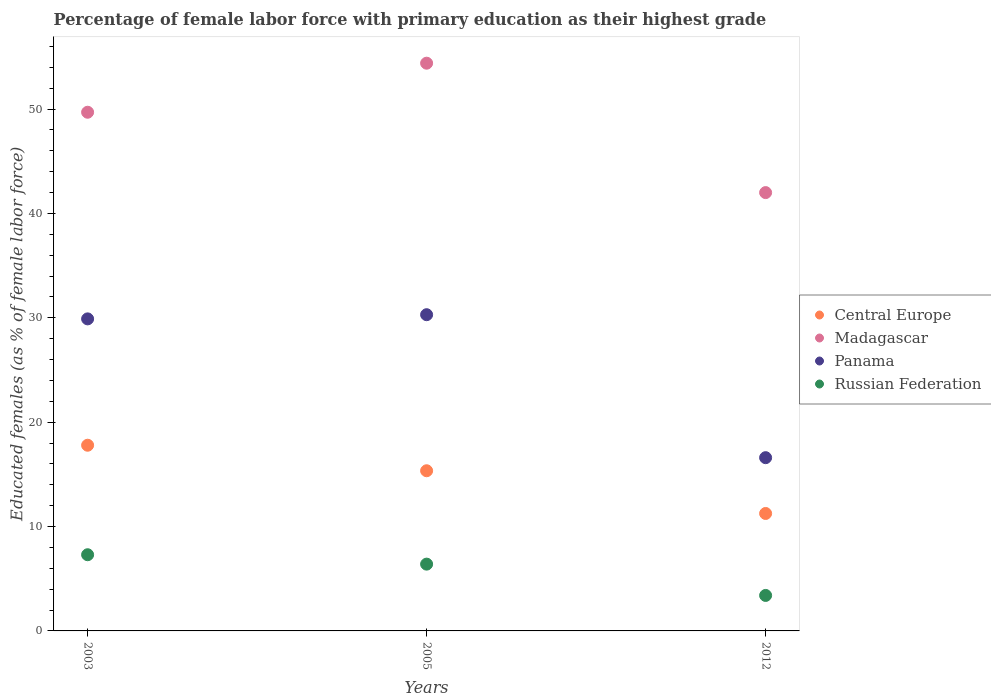What is the percentage of female labor force with primary education in Madagascar in 2003?
Offer a terse response. 49.7. Across all years, what is the maximum percentage of female labor force with primary education in Russian Federation?
Offer a very short reply. 7.3. Across all years, what is the minimum percentage of female labor force with primary education in Central Europe?
Ensure brevity in your answer.  11.25. In which year was the percentage of female labor force with primary education in Panama maximum?
Offer a very short reply. 2005. In which year was the percentage of female labor force with primary education in Panama minimum?
Your answer should be compact. 2012. What is the total percentage of female labor force with primary education in Madagascar in the graph?
Provide a short and direct response. 146.1. What is the difference between the percentage of female labor force with primary education in Russian Federation in 2003 and that in 2005?
Give a very brief answer. 0.9. What is the difference between the percentage of female labor force with primary education in Panama in 2003 and the percentage of female labor force with primary education in Russian Federation in 2012?
Make the answer very short. 26.5. What is the average percentage of female labor force with primary education in Panama per year?
Offer a very short reply. 25.6. In the year 2005, what is the difference between the percentage of female labor force with primary education in Madagascar and percentage of female labor force with primary education in Russian Federation?
Offer a very short reply. 48. In how many years, is the percentage of female labor force with primary education in Panama greater than 24 %?
Provide a short and direct response. 2. What is the ratio of the percentage of female labor force with primary education in Madagascar in 2005 to that in 2012?
Provide a short and direct response. 1.3. Is the percentage of female labor force with primary education in Russian Federation in 2003 less than that in 2012?
Provide a short and direct response. No. What is the difference between the highest and the second highest percentage of female labor force with primary education in Panama?
Your answer should be compact. 0.4. What is the difference between the highest and the lowest percentage of female labor force with primary education in Russian Federation?
Provide a succinct answer. 3.9. In how many years, is the percentage of female labor force with primary education in Central Europe greater than the average percentage of female labor force with primary education in Central Europe taken over all years?
Give a very brief answer. 2. Is the sum of the percentage of female labor force with primary education in Panama in 2003 and 2012 greater than the maximum percentage of female labor force with primary education in Madagascar across all years?
Make the answer very short. No. Is it the case that in every year, the sum of the percentage of female labor force with primary education in Madagascar and percentage of female labor force with primary education in Central Europe  is greater than the sum of percentage of female labor force with primary education in Panama and percentage of female labor force with primary education in Russian Federation?
Provide a short and direct response. Yes. Is it the case that in every year, the sum of the percentage of female labor force with primary education in Russian Federation and percentage of female labor force with primary education in Panama  is greater than the percentage of female labor force with primary education in Central Europe?
Your answer should be very brief. Yes. Is the percentage of female labor force with primary education in Madagascar strictly less than the percentage of female labor force with primary education in Russian Federation over the years?
Your response must be concise. No. Does the graph contain any zero values?
Make the answer very short. No. What is the title of the graph?
Ensure brevity in your answer.  Percentage of female labor force with primary education as their highest grade. What is the label or title of the X-axis?
Your answer should be compact. Years. What is the label or title of the Y-axis?
Make the answer very short. Educated females (as % of female labor force). What is the Educated females (as % of female labor force) of Central Europe in 2003?
Offer a terse response. 17.79. What is the Educated females (as % of female labor force) in Madagascar in 2003?
Offer a terse response. 49.7. What is the Educated females (as % of female labor force) in Panama in 2003?
Keep it short and to the point. 29.9. What is the Educated females (as % of female labor force) in Russian Federation in 2003?
Provide a short and direct response. 7.3. What is the Educated females (as % of female labor force) in Central Europe in 2005?
Provide a succinct answer. 15.35. What is the Educated females (as % of female labor force) in Madagascar in 2005?
Offer a very short reply. 54.4. What is the Educated females (as % of female labor force) in Panama in 2005?
Your response must be concise. 30.3. What is the Educated females (as % of female labor force) of Russian Federation in 2005?
Your response must be concise. 6.4. What is the Educated females (as % of female labor force) in Central Europe in 2012?
Provide a short and direct response. 11.25. What is the Educated females (as % of female labor force) of Madagascar in 2012?
Your answer should be very brief. 42. What is the Educated females (as % of female labor force) in Panama in 2012?
Your answer should be compact. 16.6. What is the Educated females (as % of female labor force) in Russian Federation in 2012?
Ensure brevity in your answer.  3.4. Across all years, what is the maximum Educated females (as % of female labor force) in Central Europe?
Provide a succinct answer. 17.79. Across all years, what is the maximum Educated females (as % of female labor force) of Madagascar?
Your response must be concise. 54.4. Across all years, what is the maximum Educated females (as % of female labor force) of Panama?
Your response must be concise. 30.3. Across all years, what is the maximum Educated females (as % of female labor force) in Russian Federation?
Provide a short and direct response. 7.3. Across all years, what is the minimum Educated females (as % of female labor force) in Central Europe?
Provide a succinct answer. 11.25. Across all years, what is the minimum Educated females (as % of female labor force) of Panama?
Provide a succinct answer. 16.6. Across all years, what is the minimum Educated females (as % of female labor force) of Russian Federation?
Offer a very short reply. 3.4. What is the total Educated females (as % of female labor force) of Central Europe in the graph?
Your response must be concise. 44.39. What is the total Educated females (as % of female labor force) in Madagascar in the graph?
Provide a succinct answer. 146.1. What is the total Educated females (as % of female labor force) of Panama in the graph?
Your answer should be compact. 76.8. What is the difference between the Educated females (as % of female labor force) of Central Europe in 2003 and that in 2005?
Your answer should be very brief. 2.45. What is the difference between the Educated females (as % of female labor force) of Madagascar in 2003 and that in 2005?
Give a very brief answer. -4.7. What is the difference between the Educated females (as % of female labor force) of Central Europe in 2003 and that in 2012?
Give a very brief answer. 6.54. What is the difference between the Educated females (as % of female labor force) in Madagascar in 2003 and that in 2012?
Keep it short and to the point. 7.7. What is the difference between the Educated females (as % of female labor force) in Central Europe in 2005 and that in 2012?
Your answer should be very brief. 4.09. What is the difference between the Educated females (as % of female labor force) of Madagascar in 2005 and that in 2012?
Your answer should be compact. 12.4. What is the difference between the Educated females (as % of female labor force) of Central Europe in 2003 and the Educated females (as % of female labor force) of Madagascar in 2005?
Provide a short and direct response. -36.61. What is the difference between the Educated females (as % of female labor force) in Central Europe in 2003 and the Educated females (as % of female labor force) in Panama in 2005?
Your answer should be compact. -12.51. What is the difference between the Educated females (as % of female labor force) of Central Europe in 2003 and the Educated females (as % of female labor force) of Russian Federation in 2005?
Provide a short and direct response. 11.39. What is the difference between the Educated females (as % of female labor force) of Madagascar in 2003 and the Educated females (as % of female labor force) of Panama in 2005?
Offer a terse response. 19.4. What is the difference between the Educated females (as % of female labor force) of Madagascar in 2003 and the Educated females (as % of female labor force) of Russian Federation in 2005?
Make the answer very short. 43.3. What is the difference between the Educated females (as % of female labor force) in Central Europe in 2003 and the Educated females (as % of female labor force) in Madagascar in 2012?
Make the answer very short. -24.21. What is the difference between the Educated females (as % of female labor force) in Central Europe in 2003 and the Educated females (as % of female labor force) in Panama in 2012?
Your response must be concise. 1.19. What is the difference between the Educated females (as % of female labor force) of Central Europe in 2003 and the Educated females (as % of female labor force) of Russian Federation in 2012?
Make the answer very short. 14.39. What is the difference between the Educated females (as % of female labor force) in Madagascar in 2003 and the Educated females (as % of female labor force) in Panama in 2012?
Keep it short and to the point. 33.1. What is the difference between the Educated females (as % of female labor force) of Madagascar in 2003 and the Educated females (as % of female labor force) of Russian Federation in 2012?
Keep it short and to the point. 46.3. What is the difference between the Educated females (as % of female labor force) of Central Europe in 2005 and the Educated females (as % of female labor force) of Madagascar in 2012?
Keep it short and to the point. -26.65. What is the difference between the Educated females (as % of female labor force) of Central Europe in 2005 and the Educated females (as % of female labor force) of Panama in 2012?
Keep it short and to the point. -1.25. What is the difference between the Educated females (as % of female labor force) of Central Europe in 2005 and the Educated females (as % of female labor force) of Russian Federation in 2012?
Provide a succinct answer. 11.95. What is the difference between the Educated females (as % of female labor force) in Madagascar in 2005 and the Educated females (as % of female labor force) in Panama in 2012?
Provide a short and direct response. 37.8. What is the difference between the Educated females (as % of female labor force) in Madagascar in 2005 and the Educated females (as % of female labor force) in Russian Federation in 2012?
Offer a very short reply. 51. What is the difference between the Educated females (as % of female labor force) in Panama in 2005 and the Educated females (as % of female labor force) in Russian Federation in 2012?
Offer a very short reply. 26.9. What is the average Educated females (as % of female labor force) of Central Europe per year?
Provide a short and direct response. 14.8. What is the average Educated females (as % of female labor force) in Madagascar per year?
Offer a very short reply. 48.7. What is the average Educated females (as % of female labor force) in Panama per year?
Keep it short and to the point. 25.6. In the year 2003, what is the difference between the Educated females (as % of female labor force) in Central Europe and Educated females (as % of female labor force) in Madagascar?
Provide a succinct answer. -31.91. In the year 2003, what is the difference between the Educated females (as % of female labor force) of Central Europe and Educated females (as % of female labor force) of Panama?
Offer a very short reply. -12.11. In the year 2003, what is the difference between the Educated females (as % of female labor force) of Central Europe and Educated females (as % of female labor force) of Russian Federation?
Provide a succinct answer. 10.49. In the year 2003, what is the difference between the Educated females (as % of female labor force) in Madagascar and Educated females (as % of female labor force) in Panama?
Keep it short and to the point. 19.8. In the year 2003, what is the difference between the Educated females (as % of female labor force) in Madagascar and Educated females (as % of female labor force) in Russian Federation?
Your response must be concise. 42.4. In the year 2003, what is the difference between the Educated females (as % of female labor force) of Panama and Educated females (as % of female labor force) of Russian Federation?
Give a very brief answer. 22.6. In the year 2005, what is the difference between the Educated females (as % of female labor force) in Central Europe and Educated females (as % of female labor force) in Madagascar?
Offer a terse response. -39.05. In the year 2005, what is the difference between the Educated females (as % of female labor force) of Central Europe and Educated females (as % of female labor force) of Panama?
Ensure brevity in your answer.  -14.95. In the year 2005, what is the difference between the Educated females (as % of female labor force) in Central Europe and Educated females (as % of female labor force) in Russian Federation?
Make the answer very short. 8.95. In the year 2005, what is the difference between the Educated females (as % of female labor force) of Madagascar and Educated females (as % of female labor force) of Panama?
Keep it short and to the point. 24.1. In the year 2005, what is the difference between the Educated females (as % of female labor force) in Madagascar and Educated females (as % of female labor force) in Russian Federation?
Your response must be concise. 48. In the year 2005, what is the difference between the Educated females (as % of female labor force) in Panama and Educated females (as % of female labor force) in Russian Federation?
Ensure brevity in your answer.  23.9. In the year 2012, what is the difference between the Educated females (as % of female labor force) of Central Europe and Educated females (as % of female labor force) of Madagascar?
Offer a terse response. -30.75. In the year 2012, what is the difference between the Educated females (as % of female labor force) of Central Europe and Educated females (as % of female labor force) of Panama?
Give a very brief answer. -5.35. In the year 2012, what is the difference between the Educated females (as % of female labor force) in Central Europe and Educated females (as % of female labor force) in Russian Federation?
Ensure brevity in your answer.  7.85. In the year 2012, what is the difference between the Educated females (as % of female labor force) of Madagascar and Educated females (as % of female labor force) of Panama?
Your response must be concise. 25.4. In the year 2012, what is the difference between the Educated females (as % of female labor force) of Madagascar and Educated females (as % of female labor force) of Russian Federation?
Provide a short and direct response. 38.6. In the year 2012, what is the difference between the Educated females (as % of female labor force) of Panama and Educated females (as % of female labor force) of Russian Federation?
Ensure brevity in your answer.  13.2. What is the ratio of the Educated females (as % of female labor force) of Central Europe in 2003 to that in 2005?
Ensure brevity in your answer.  1.16. What is the ratio of the Educated females (as % of female labor force) of Madagascar in 2003 to that in 2005?
Ensure brevity in your answer.  0.91. What is the ratio of the Educated females (as % of female labor force) in Panama in 2003 to that in 2005?
Your response must be concise. 0.99. What is the ratio of the Educated females (as % of female labor force) in Russian Federation in 2003 to that in 2005?
Give a very brief answer. 1.14. What is the ratio of the Educated females (as % of female labor force) in Central Europe in 2003 to that in 2012?
Provide a succinct answer. 1.58. What is the ratio of the Educated females (as % of female labor force) of Madagascar in 2003 to that in 2012?
Give a very brief answer. 1.18. What is the ratio of the Educated females (as % of female labor force) of Panama in 2003 to that in 2012?
Keep it short and to the point. 1.8. What is the ratio of the Educated females (as % of female labor force) of Russian Federation in 2003 to that in 2012?
Offer a terse response. 2.15. What is the ratio of the Educated females (as % of female labor force) in Central Europe in 2005 to that in 2012?
Make the answer very short. 1.36. What is the ratio of the Educated females (as % of female labor force) of Madagascar in 2005 to that in 2012?
Offer a terse response. 1.3. What is the ratio of the Educated females (as % of female labor force) of Panama in 2005 to that in 2012?
Provide a short and direct response. 1.83. What is the ratio of the Educated females (as % of female labor force) in Russian Federation in 2005 to that in 2012?
Keep it short and to the point. 1.88. What is the difference between the highest and the second highest Educated females (as % of female labor force) in Central Europe?
Your answer should be very brief. 2.45. What is the difference between the highest and the second highest Educated females (as % of female labor force) of Madagascar?
Ensure brevity in your answer.  4.7. What is the difference between the highest and the lowest Educated females (as % of female labor force) in Central Europe?
Give a very brief answer. 6.54. What is the difference between the highest and the lowest Educated females (as % of female labor force) in Panama?
Provide a short and direct response. 13.7. 